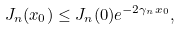<formula> <loc_0><loc_0><loc_500><loc_500>J _ { n } ( x _ { 0 } ) \leq J _ { n } ( 0 ) e ^ { - 2 \gamma _ { n } x _ { 0 } } ,</formula> 